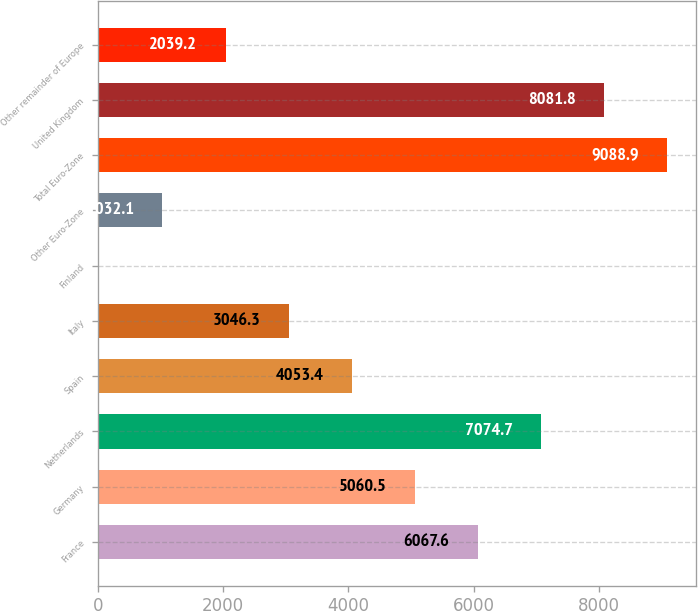Convert chart to OTSL. <chart><loc_0><loc_0><loc_500><loc_500><bar_chart><fcel>France<fcel>Germany<fcel>Netherlands<fcel>Spain<fcel>Italy<fcel>Finland<fcel>Other Euro-Zone<fcel>Total Euro-Zone<fcel>United Kingdom<fcel>Other remainder of Europe<nl><fcel>6067.6<fcel>5060.5<fcel>7074.7<fcel>4053.4<fcel>3046.3<fcel>25<fcel>1032.1<fcel>9088.9<fcel>8081.8<fcel>2039.2<nl></chart> 